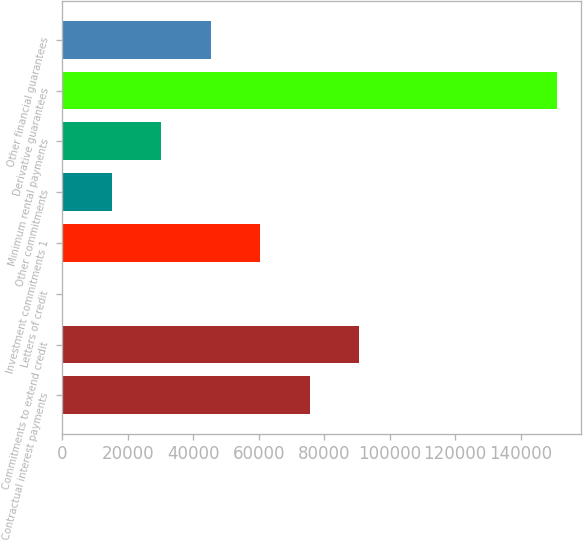Convert chart. <chart><loc_0><loc_0><loc_500><loc_500><bar_chart><fcel>Contractual interest payments<fcel>Commitments to extend credit<fcel>Letters of credit<fcel>Investment commitments 1<fcel>Other commitments<fcel>Minimum rental payments<fcel>Derivative guarantees<fcel>Other financial guarantees<nl><fcel>75501.5<fcel>90599<fcel>14<fcel>60404<fcel>15111.5<fcel>30209<fcel>150989<fcel>45306.5<nl></chart> 